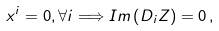Convert formula to latex. <formula><loc_0><loc_0><loc_500><loc_500>x ^ { i } = 0 , \forall i \Longrightarrow I m \left ( D _ { i } Z \right ) = 0 \, ,</formula> 